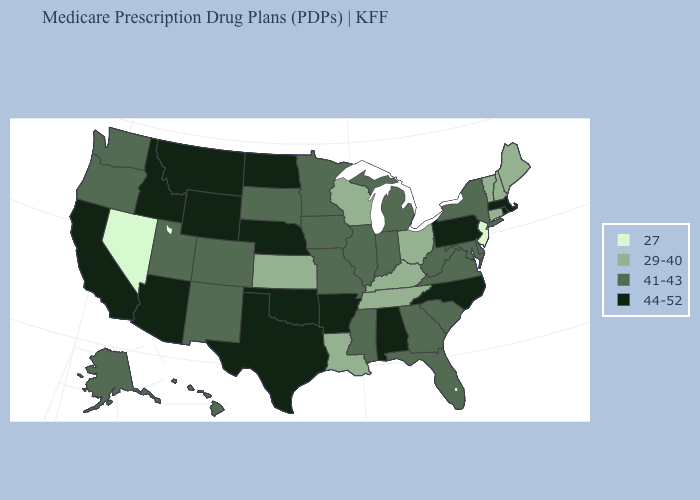What is the value of Maryland?
Keep it brief. 41-43. What is the lowest value in states that border Vermont?
Be succinct. 29-40. Which states have the lowest value in the South?
Answer briefly. Kentucky, Louisiana, Tennessee. What is the lowest value in the USA?
Concise answer only. 27. What is the value of Alabama?
Keep it brief. 44-52. What is the value of Tennessee?
Short answer required. 29-40. Does the map have missing data?
Concise answer only. No. Name the states that have a value in the range 44-52?
Write a very short answer. Alabama, Arkansas, Arizona, California, Idaho, Massachusetts, Montana, North Carolina, North Dakota, Nebraska, Oklahoma, Pennsylvania, Rhode Island, Texas, Wyoming. What is the value of Wyoming?
Keep it brief. 44-52. Name the states that have a value in the range 44-52?
Give a very brief answer. Alabama, Arkansas, Arizona, California, Idaho, Massachusetts, Montana, North Carolina, North Dakota, Nebraska, Oklahoma, Pennsylvania, Rhode Island, Texas, Wyoming. Name the states that have a value in the range 44-52?
Keep it brief. Alabama, Arkansas, Arizona, California, Idaho, Massachusetts, Montana, North Carolina, North Dakota, Nebraska, Oklahoma, Pennsylvania, Rhode Island, Texas, Wyoming. What is the highest value in the Northeast ?
Concise answer only. 44-52. Name the states that have a value in the range 29-40?
Short answer required. Connecticut, Kansas, Kentucky, Louisiana, Maine, New Hampshire, Ohio, Tennessee, Vermont, Wisconsin. What is the highest value in the USA?
Quick response, please. 44-52. Name the states that have a value in the range 27?
Write a very short answer. New Jersey, Nevada. 